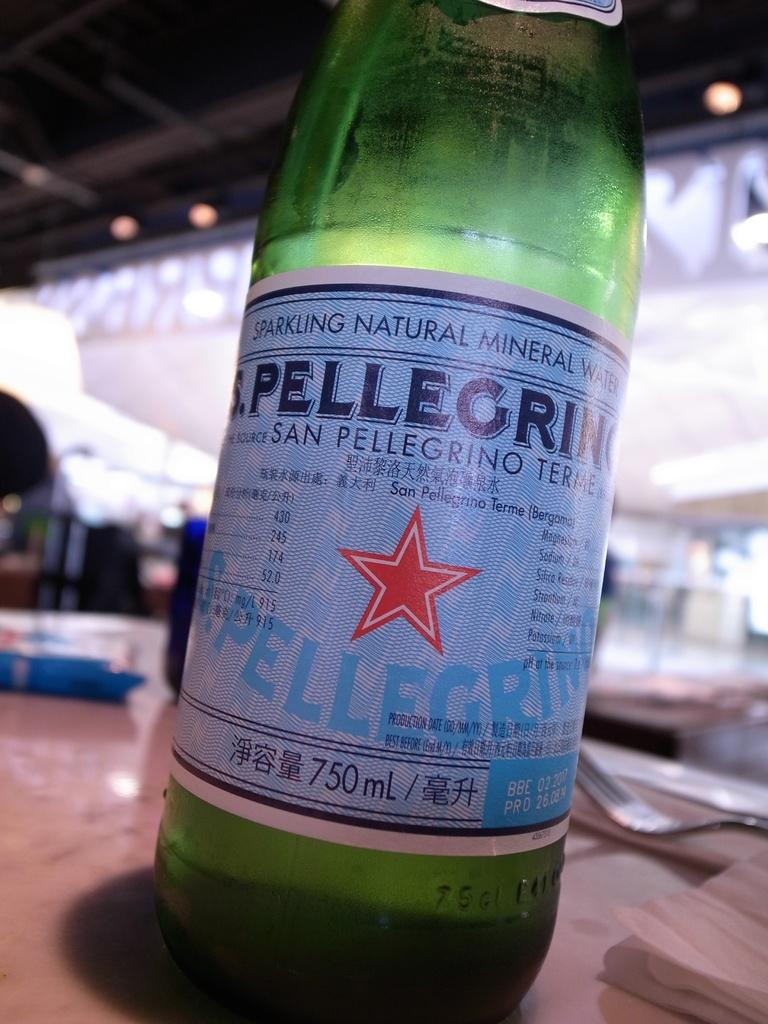<image>
Present a compact description of the photo's key features. A bottle of Pellegrino water sits on a table. 